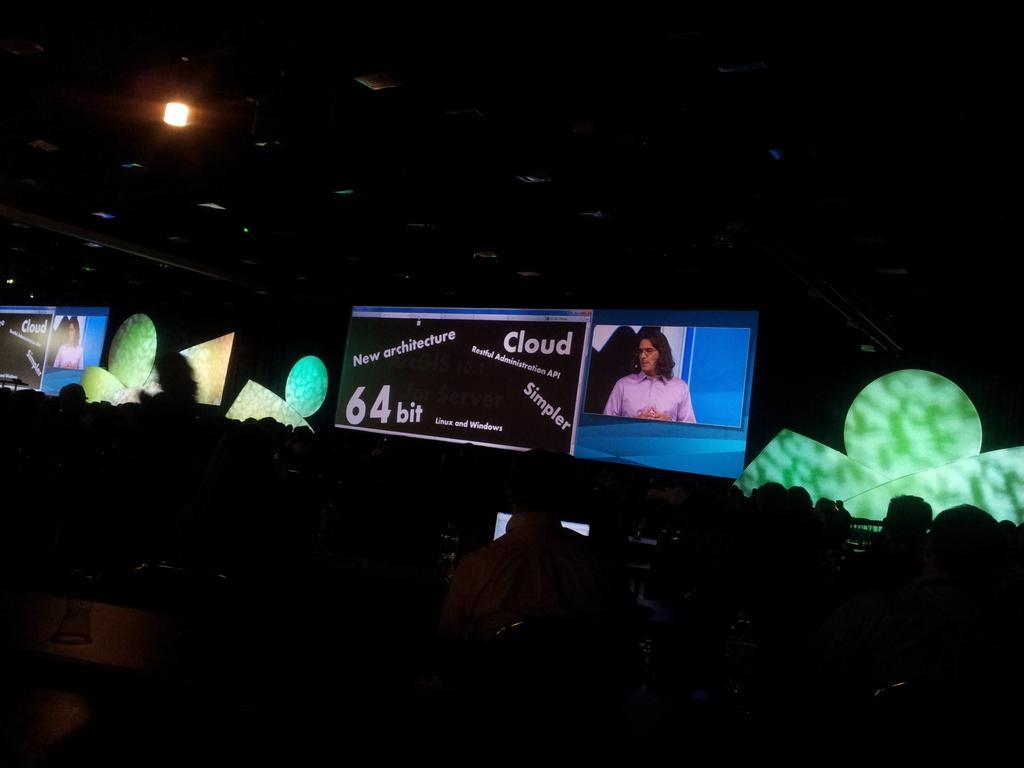How would you summarize this image in a sentence or two? This image is taken indoors. This image is a little dark. In the middle of the image there are a few people. At the top of the image there is a light. In the background there are a few banners with text on them and there is a screen. There are a few objects. 